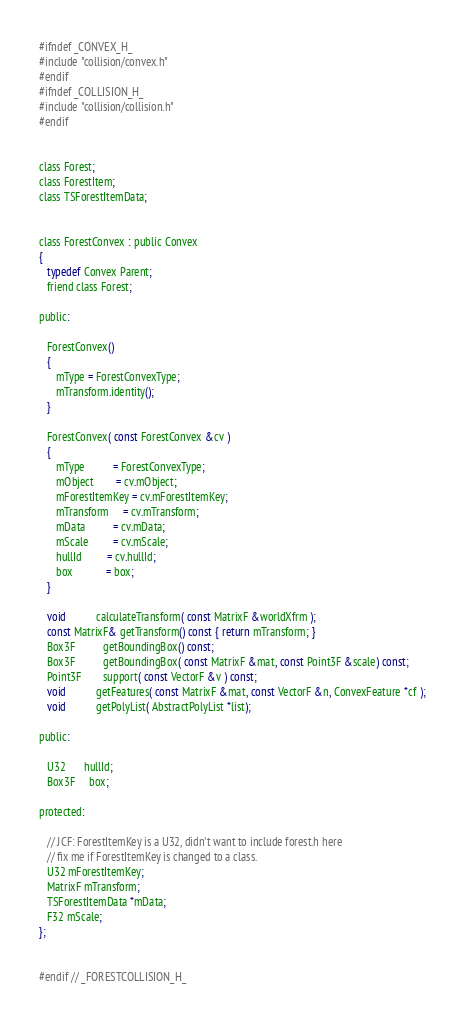<code> <loc_0><loc_0><loc_500><loc_500><_C_>#ifndef _CONVEX_H_
#include "collision/convex.h"
#endif
#ifndef _COLLISION_H_
#include "collision/collision.h"
#endif


class Forest;
class ForestItem;
class TSForestItemData;


class ForestConvex : public Convex
{
   typedef Convex Parent;
   friend class Forest;

public:

   ForestConvex() 
   { 
      mType = ForestConvexType; 
      mTransform.identity(); 
   }

   ForestConvex( const ForestConvex &cv ) 
   {
      mType          = ForestConvexType;
      mObject        = cv.mObject;
      mForestItemKey = cv.mForestItemKey;
      mTransform     = cv.mTransform;
      mData          = cv.mData;
      mScale         = cv.mScale;
      hullId         = cv.hullId;
      box            = box;
   }

   void           calculateTransform( const MatrixF &worldXfrm );
   const MatrixF& getTransform() const { return mTransform; }
   Box3F          getBoundingBox() const;
   Box3F          getBoundingBox( const MatrixF &mat, const Point3F &scale) const;
   Point3F        support( const VectorF &v ) const;
   void           getFeatures( const MatrixF &mat, const VectorF &n, ConvexFeature *cf );
   void           getPolyList( AbstractPolyList *list);

public:

   U32       hullId;
   Box3F     box;

protected:

   // JCF: ForestItemKey is a U32, didn't want to include forest.h here
   // fix me if ForestItemKey is changed to a class.
   U32 mForestItemKey;
   MatrixF mTransform;
   TSForestItemData *mData;
   F32 mScale;
};


#endif // _FORESTCOLLISION_H_</code> 